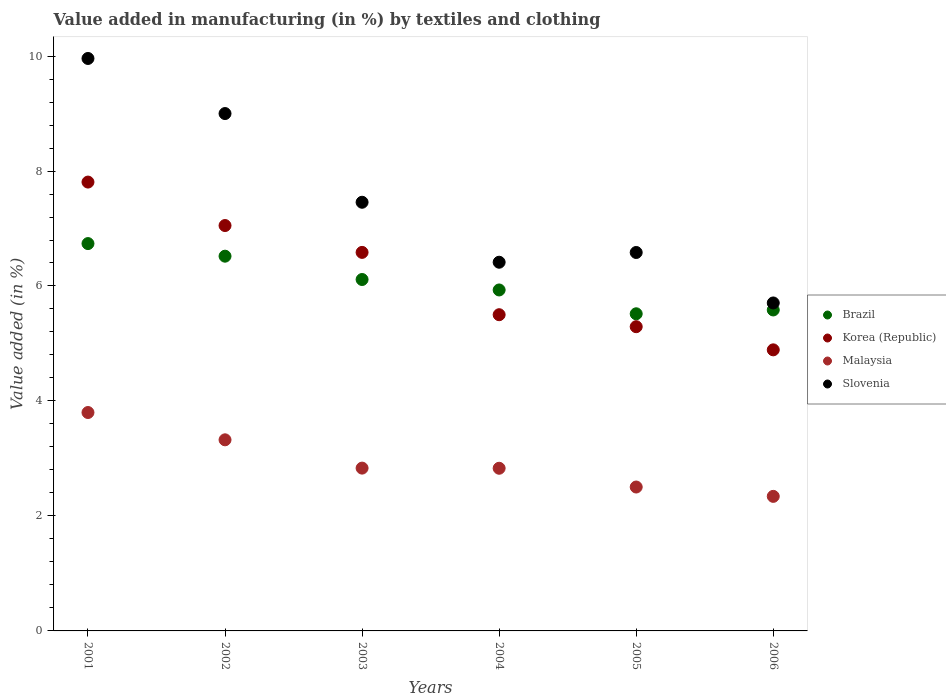How many different coloured dotlines are there?
Provide a succinct answer. 4. What is the percentage of value added in manufacturing by textiles and clothing in Malaysia in 2002?
Make the answer very short. 3.32. Across all years, what is the maximum percentage of value added in manufacturing by textiles and clothing in Brazil?
Your answer should be compact. 6.74. Across all years, what is the minimum percentage of value added in manufacturing by textiles and clothing in Brazil?
Provide a short and direct response. 5.52. In which year was the percentage of value added in manufacturing by textiles and clothing in Slovenia minimum?
Ensure brevity in your answer.  2006. What is the total percentage of value added in manufacturing by textiles and clothing in Korea (Republic) in the graph?
Offer a terse response. 37.13. What is the difference between the percentage of value added in manufacturing by textiles and clothing in Korea (Republic) in 2003 and that in 2006?
Provide a succinct answer. 1.7. What is the difference between the percentage of value added in manufacturing by textiles and clothing in Slovenia in 2004 and the percentage of value added in manufacturing by textiles and clothing in Korea (Republic) in 2001?
Ensure brevity in your answer.  -1.39. What is the average percentage of value added in manufacturing by textiles and clothing in Slovenia per year?
Ensure brevity in your answer.  7.52. In the year 2001, what is the difference between the percentage of value added in manufacturing by textiles and clothing in Brazil and percentage of value added in manufacturing by textiles and clothing in Slovenia?
Your answer should be very brief. -3.22. In how many years, is the percentage of value added in manufacturing by textiles and clothing in Brazil greater than 9.6 %?
Make the answer very short. 0. What is the ratio of the percentage of value added in manufacturing by textiles and clothing in Korea (Republic) in 2001 to that in 2002?
Provide a succinct answer. 1.11. What is the difference between the highest and the second highest percentage of value added in manufacturing by textiles and clothing in Brazil?
Ensure brevity in your answer.  0.22. What is the difference between the highest and the lowest percentage of value added in manufacturing by textiles and clothing in Korea (Republic)?
Offer a terse response. 2.92. In how many years, is the percentage of value added in manufacturing by textiles and clothing in Brazil greater than the average percentage of value added in manufacturing by textiles and clothing in Brazil taken over all years?
Your answer should be very brief. 3. Is it the case that in every year, the sum of the percentage of value added in manufacturing by textiles and clothing in Korea (Republic) and percentage of value added in manufacturing by textiles and clothing in Slovenia  is greater than the percentage of value added in manufacturing by textiles and clothing in Brazil?
Your answer should be very brief. Yes. Is the percentage of value added in manufacturing by textiles and clothing in Malaysia strictly greater than the percentage of value added in manufacturing by textiles and clothing in Slovenia over the years?
Give a very brief answer. No. What is the difference between two consecutive major ticks on the Y-axis?
Provide a succinct answer. 2. Are the values on the major ticks of Y-axis written in scientific E-notation?
Your answer should be very brief. No. Does the graph contain any zero values?
Your response must be concise. No. Where does the legend appear in the graph?
Give a very brief answer. Center right. How are the legend labels stacked?
Your answer should be compact. Vertical. What is the title of the graph?
Provide a short and direct response. Value added in manufacturing (in %) by textiles and clothing. Does "Bhutan" appear as one of the legend labels in the graph?
Your response must be concise. No. What is the label or title of the Y-axis?
Provide a short and direct response. Value added (in %). What is the Value added (in %) in Brazil in 2001?
Make the answer very short. 6.74. What is the Value added (in %) of Korea (Republic) in 2001?
Ensure brevity in your answer.  7.81. What is the Value added (in %) in Malaysia in 2001?
Keep it short and to the point. 3.8. What is the Value added (in %) of Slovenia in 2001?
Your response must be concise. 9.96. What is the Value added (in %) in Brazil in 2002?
Your answer should be very brief. 6.52. What is the Value added (in %) in Korea (Republic) in 2002?
Keep it short and to the point. 7.05. What is the Value added (in %) in Malaysia in 2002?
Ensure brevity in your answer.  3.32. What is the Value added (in %) of Slovenia in 2002?
Provide a succinct answer. 9. What is the Value added (in %) of Brazil in 2003?
Offer a very short reply. 6.11. What is the Value added (in %) of Korea (Republic) in 2003?
Keep it short and to the point. 6.58. What is the Value added (in %) of Malaysia in 2003?
Your answer should be compact. 2.83. What is the Value added (in %) of Slovenia in 2003?
Ensure brevity in your answer.  7.46. What is the Value added (in %) in Brazil in 2004?
Make the answer very short. 5.93. What is the Value added (in %) in Korea (Republic) in 2004?
Your response must be concise. 5.5. What is the Value added (in %) of Malaysia in 2004?
Your response must be concise. 2.83. What is the Value added (in %) of Slovenia in 2004?
Give a very brief answer. 6.41. What is the Value added (in %) in Brazil in 2005?
Offer a terse response. 5.52. What is the Value added (in %) of Korea (Republic) in 2005?
Your response must be concise. 5.29. What is the Value added (in %) of Malaysia in 2005?
Provide a short and direct response. 2.5. What is the Value added (in %) of Slovenia in 2005?
Keep it short and to the point. 6.58. What is the Value added (in %) of Brazil in 2006?
Your response must be concise. 5.58. What is the Value added (in %) of Korea (Republic) in 2006?
Ensure brevity in your answer.  4.89. What is the Value added (in %) of Malaysia in 2006?
Give a very brief answer. 2.34. What is the Value added (in %) of Slovenia in 2006?
Make the answer very short. 5.7. Across all years, what is the maximum Value added (in %) in Brazil?
Offer a very short reply. 6.74. Across all years, what is the maximum Value added (in %) of Korea (Republic)?
Provide a succinct answer. 7.81. Across all years, what is the maximum Value added (in %) of Malaysia?
Offer a very short reply. 3.8. Across all years, what is the maximum Value added (in %) of Slovenia?
Offer a very short reply. 9.96. Across all years, what is the minimum Value added (in %) in Brazil?
Your answer should be very brief. 5.52. Across all years, what is the minimum Value added (in %) of Korea (Republic)?
Make the answer very short. 4.89. Across all years, what is the minimum Value added (in %) in Malaysia?
Provide a short and direct response. 2.34. Across all years, what is the minimum Value added (in %) in Slovenia?
Offer a terse response. 5.7. What is the total Value added (in %) of Brazil in the graph?
Ensure brevity in your answer.  36.4. What is the total Value added (in %) of Korea (Republic) in the graph?
Offer a very short reply. 37.13. What is the total Value added (in %) of Malaysia in the graph?
Your response must be concise. 17.63. What is the total Value added (in %) in Slovenia in the graph?
Offer a very short reply. 45.11. What is the difference between the Value added (in %) in Brazil in 2001 and that in 2002?
Keep it short and to the point. 0.22. What is the difference between the Value added (in %) of Korea (Republic) in 2001 and that in 2002?
Ensure brevity in your answer.  0.76. What is the difference between the Value added (in %) of Malaysia in 2001 and that in 2002?
Offer a very short reply. 0.47. What is the difference between the Value added (in %) in Slovenia in 2001 and that in 2002?
Keep it short and to the point. 0.96. What is the difference between the Value added (in %) in Brazil in 2001 and that in 2003?
Make the answer very short. 0.62. What is the difference between the Value added (in %) of Korea (Republic) in 2001 and that in 2003?
Provide a short and direct response. 1.22. What is the difference between the Value added (in %) in Malaysia in 2001 and that in 2003?
Offer a very short reply. 0.97. What is the difference between the Value added (in %) in Slovenia in 2001 and that in 2003?
Your answer should be very brief. 2.5. What is the difference between the Value added (in %) of Brazil in 2001 and that in 2004?
Provide a succinct answer. 0.81. What is the difference between the Value added (in %) in Korea (Republic) in 2001 and that in 2004?
Provide a succinct answer. 2.31. What is the difference between the Value added (in %) of Malaysia in 2001 and that in 2004?
Your answer should be compact. 0.97. What is the difference between the Value added (in %) of Slovenia in 2001 and that in 2004?
Offer a terse response. 3.54. What is the difference between the Value added (in %) in Brazil in 2001 and that in 2005?
Make the answer very short. 1.22. What is the difference between the Value added (in %) in Korea (Republic) in 2001 and that in 2005?
Make the answer very short. 2.52. What is the difference between the Value added (in %) of Malaysia in 2001 and that in 2005?
Make the answer very short. 1.3. What is the difference between the Value added (in %) of Slovenia in 2001 and that in 2005?
Offer a very short reply. 3.38. What is the difference between the Value added (in %) in Brazil in 2001 and that in 2006?
Give a very brief answer. 1.15. What is the difference between the Value added (in %) in Korea (Republic) in 2001 and that in 2006?
Ensure brevity in your answer.  2.92. What is the difference between the Value added (in %) of Malaysia in 2001 and that in 2006?
Offer a very short reply. 1.46. What is the difference between the Value added (in %) in Slovenia in 2001 and that in 2006?
Your answer should be compact. 4.25. What is the difference between the Value added (in %) of Brazil in 2002 and that in 2003?
Your response must be concise. 0.41. What is the difference between the Value added (in %) of Korea (Republic) in 2002 and that in 2003?
Offer a very short reply. 0.47. What is the difference between the Value added (in %) of Malaysia in 2002 and that in 2003?
Your answer should be very brief. 0.49. What is the difference between the Value added (in %) in Slovenia in 2002 and that in 2003?
Ensure brevity in your answer.  1.54. What is the difference between the Value added (in %) in Brazil in 2002 and that in 2004?
Give a very brief answer. 0.59. What is the difference between the Value added (in %) of Korea (Republic) in 2002 and that in 2004?
Your response must be concise. 1.55. What is the difference between the Value added (in %) in Malaysia in 2002 and that in 2004?
Offer a very short reply. 0.49. What is the difference between the Value added (in %) of Slovenia in 2002 and that in 2004?
Keep it short and to the point. 2.59. What is the difference between the Value added (in %) in Brazil in 2002 and that in 2005?
Your answer should be compact. 1. What is the difference between the Value added (in %) in Korea (Republic) in 2002 and that in 2005?
Keep it short and to the point. 1.76. What is the difference between the Value added (in %) in Malaysia in 2002 and that in 2005?
Your answer should be compact. 0.82. What is the difference between the Value added (in %) in Slovenia in 2002 and that in 2005?
Ensure brevity in your answer.  2.42. What is the difference between the Value added (in %) in Brazil in 2002 and that in 2006?
Your response must be concise. 0.94. What is the difference between the Value added (in %) of Korea (Republic) in 2002 and that in 2006?
Your answer should be very brief. 2.16. What is the difference between the Value added (in %) in Malaysia in 2002 and that in 2006?
Your response must be concise. 0.98. What is the difference between the Value added (in %) of Slovenia in 2002 and that in 2006?
Provide a succinct answer. 3.29. What is the difference between the Value added (in %) of Brazil in 2003 and that in 2004?
Your answer should be compact. 0.18. What is the difference between the Value added (in %) in Korea (Republic) in 2003 and that in 2004?
Your answer should be very brief. 1.08. What is the difference between the Value added (in %) in Malaysia in 2003 and that in 2004?
Offer a terse response. 0. What is the difference between the Value added (in %) of Slovenia in 2003 and that in 2004?
Offer a very short reply. 1.04. What is the difference between the Value added (in %) in Brazil in 2003 and that in 2005?
Provide a short and direct response. 0.6. What is the difference between the Value added (in %) of Korea (Republic) in 2003 and that in 2005?
Offer a very short reply. 1.29. What is the difference between the Value added (in %) of Malaysia in 2003 and that in 2005?
Your answer should be compact. 0.33. What is the difference between the Value added (in %) in Slovenia in 2003 and that in 2005?
Provide a succinct answer. 0.87. What is the difference between the Value added (in %) in Brazil in 2003 and that in 2006?
Provide a short and direct response. 0.53. What is the difference between the Value added (in %) in Korea (Republic) in 2003 and that in 2006?
Your answer should be compact. 1.7. What is the difference between the Value added (in %) in Malaysia in 2003 and that in 2006?
Provide a short and direct response. 0.49. What is the difference between the Value added (in %) of Slovenia in 2003 and that in 2006?
Provide a succinct answer. 1.75. What is the difference between the Value added (in %) of Brazil in 2004 and that in 2005?
Your answer should be very brief. 0.41. What is the difference between the Value added (in %) in Korea (Republic) in 2004 and that in 2005?
Your answer should be very brief. 0.21. What is the difference between the Value added (in %) of Malaysia in 2004 and that in 2005?
Offer a terse response. 0.33. What is the difference between the Value added (in %) in Slovenia in 2004 and that in 2005?
Provide a short and direct response. -0.17. What is the difference between the Value added (in %) of Brazil in 2004 and that in 2006?
Provide a succinct answer. 0.35. What is the difference between the Value added (in %) in Korea (Republic) in 2004 and that in 2006?
Your answer should be very brief. 0.61. What is the difference between the Value added (in %) in Malaysia in 2004 and that in 2006?
Offer a very short reply. 0.49. What is the difference between the Value added (in %) of Slovenia in 2004 and that in 2006?
Give a very brief answer. 0.71. What is the difference between the Value added (in %) of Brazil in 2005 and that in 2006?
Make the answer very short. -0.07. What is the difference between the Value added (in %) of Korea (Republic) in 2005 and that in 2006?
Ensure brevity in your answer.  0.4. What is the difference between the Value added (in %) of Malaysia in 2005 and that in 2006?
Provide a succinct answer. 0.16. What is the difference between the Value added (in %) of Slovenia in 2005 and that in 2006?
Make the answer very short. 0.88. What is the difference between the Value added (in %) in Brazil in 2001 and the Value added (in %) in Korea (Republic) in 2002?
Give a very brief answer. -0.31. What is the difference between the Value added (in %) in Brazil in 2001 and the Value added (in %) in Malaysia in 2002?
Make the answer very short. 3.41. What is the difference between the Value added (in %) of Brazil in 2001 and the Value added (in %) of Slovenia in 2002?
Keep it short and to the point. -2.26. What is the difference between the Value added (in %) in Korea (Republic) in 2001 and the Value added (in %) in Malaysia in 2002?
Provide a short and direct response. 4.48. What is the difference between the Value added (in %) of Korea (Republic) in 2001 and the Value added (in %) of Slovenia in 2002?
Offer a terse response. -1.19. What is the difference between the Value added (in %) in Malaysia in 2001 and the Value added (in %) in Slovenia in 2002?
Give a very brief answer. -5.2. What is the difference between the Value added (in %) of Brazil in 2001 and the Value added (in %) of Korea (Republic) in 2003?
Make the answer very short. 0.15. What is the difference between the Value added (in %) in Brazil in 2001 and the Value added (in %) in Malaysia in 2003?
Keep it short and to the point. 3.91. What is the difference between the Value added (in %) in Brazil in 2001 and the Value added (in %) in Slovenia in 2003?
Provide a succinct answer. -0.72. What is the difference between the Value added (in %) of Korea (Republic) in 2001 and the Value added (in %) of Malaysia in 2003?
Offer a very short reply. 4.98. What is the difference between the Value added (in %) of Korea (Republic) in 2001 and the Value added (in %) of Slovenia in 2003?
Provide a succinct answer. 0.35. What is the difference between the Value added (in %) of Malaysia in 2001 and the Value added (in %) of Slovenia in 2003?
Provide a short and direct response. -3.66. What is the difference between the Value added (in %) of Brazil in 2001 and the Value added (in %) of Korea (Republic) in 2004?
Your response must be concise. 1.24. What is the difference between the Value added (in %) in Brazil in 2001 and the Value added (in %) in Malaysia in 2004?
Offer a terse response. 3.91. What is the difference between the Value added (in %) of Brazil in 2001 and the Value added (in %) of Slovenia in 2004?
Provide a succinct answer. 0.32. What is the difference between the Value added (in %) of Korea (Republic) in 2001 and the Value added (in %) of Malaysia in 2004?
Your answer should be compact. 4.98. What is the difference between the Value added (in %) of Korea (Republic) in 2001 and the Value added (in %) of Slovenia in 2004?
Give a very brief answer. 1.39. What is the difference between the Value added (in %) in Malaysia in 2001 and the Value added (in %) in Slovenia in 2004?
Give a very brief answer. -2.61. What is the difference between the Value added (in %) in Brazil in 2001 and the Value added (in %) in Korea (Republic) in 2005?
Provide a short and direct response. 1.45. What is the difference between the Value added (in %) in Brazil in 2001 and the Value added (in %) in Malaysia in 2005?
Your answer should be very brief. 4.23. What is the difference between the Value added (in %) in Brazil in 2001 and the Value added (in %) in Slovenia in 2005?
Keep it short and to the point. 0.15. What is the difference between the Value added (in %) of Korea (Republic) in 2001 and the Value added (in %) of Malaysia in 2005?
Ensure brevity in your answer.  5.3. What is the difference between the Value added (in %) of Korea (Republic) in 2001 and the Value added (in %) of Slovenia in 2005?
Keep it short and to the point. 1.22. What is the difference between the Value added (in %) of Malaysia in 2001 and the Value added (in %) of Slovenia in 2005?
Ensure brevity in your answer.  -2.78. What is the difference between the Value added (in %) in Brazil in 2001 and the Value added (in %) in Korea (Republic) in 2006?
Provide a succinct answer. 1.85. What is the difference between the Value added (in %) of Brazil in 2001 and the Value added (in %) of Malaysia in 2006?
Your answer should be very brief. 4.4. What is the difference between the Value added (in %) in Brazil in 2001 and the Value added (in %) in Slovenia in 2006?
Offer a very short reply. 1.03. What is the difference between the Value added (in %) in Korea (Republic) in 2001 and the Value added (in %) in Malaysia in 2006?
Give a very brief answer. 5.47. What is the difference between the Value added (in %) of Korea (Republic) in 2001 and the Value added (in %) of Slovenia in 2006?
Give a very brief answer. 2.1. What is the difference between the Value added (in %) in Malaysia in 2001 and the Value added (in %) in Slovenia in 2006?
Provide a short and direct response. -1.91. What is the difference between the Value added (in %) in Brazil in 2002 and the Value added (in %) in Korea (Republic) in 2003?
Give a very brief answer. -0.07. What is the difference between the Value added (in %) in Brazil in 2002 and the Value added (in %) in Malaysia in 2003?
Your answer should be compact. 3.69. What is the difference between the Value added (in %) in Brazil in 2002 and the Value added (in %) in Slovenia in 2003?
Make the answer very short. -0.94. What is the difference between the Value added (in %) of Korea (Republic) in 2002 and the Value added (in %) of Malaysia in 2003?
Your answer should be compact. 4.22. What is the difference between the Value added (in %) of Korea (Republic) in 2002 and the Value added (in %) of Slovenia in 2003?
Offer a very short reply. -0.4. What is the difference between the Value added (in %) in Malaysia in 2002 and the Value added (in %) in Slovenia in 2003?
Make the answer very short. -4.13. What is the difference between the Value added (in %) in Brazil in 2002 and the Value added (in %) in Korea (Republic) in 2004?
Ensure brevity in your answer.  1.02. What is the difference between the Value added (in %) of Brazil in 2002 and the Value added (in %) of Malaysia in 2004?
Offer a very short reply. 3.69. What is the difference between the Value added (in %) of Brazil in 2002 and the Value added (in %) of Slovenia in 2004?
Your response must be concise. 0.11. What is the difference between the Value added (in %) of Korea (Republic) in 2002 and the Value added (in %) of Malaysia in 2004?
Keep it short and to the point. 4.22. What is the difference between the Value added (in %) of Korea (Republic) in 2002 and the Value added (in %) of Slovenia in 2004?
Ensure brevity in your answer.  0.64. What is the difference between the Value added (in %) of Malaysia in 2002 and the Value added (in %) of Slovenia in 2004?
Make the answer very short. -3.09. What is the difference between the Value added (in %) in Brazil in 2002 and the Value added (in %) in Korea (Republic) in 2005?
Offer a terse response. 1.23. What is the difference between the Value added (in %) in Brazil in 2002 and the Value added (in %) in Malaysia in 2005?
Provide a succinct answer. 4.02. What is the difference between the Value added (in %) in Brazil in 2002 and the Value added (in %) in Slovenia in 2005?
Provide a succinct answer. -0.06. What is the difference between the Value added (in %) of Korea (Republic) in 2002 and the Value added (in %) of Malaysia in 2005?
Your answer should be very brief. 4.55. What is the difference between the Value added (in %) in Korea (Republic) in 2002 and the Value added (in %) in Slovenia in 2005?
Provide a succinct answer. 0.47. What is the difference between the Value added (in %) of Malaysia in 2002 and the Value added (in %) of Slovenia in 2005?
Your response must be concise. -3.26. What is the difference between the Value added (in %) in Brazil in 2002 and the Value added (in %) in Korea (Republic) in 2006?
Provide a short and direct response. 1.63. What is the difference between the Value added (in %) of Brazil in 2002 and the Value added (in %) of Malaysia in 2006?
Ensure brevity in your answer.  4.18. What is the difference between the Value added (in %) in Brazil in 2002 and the Value added (in %) in Slovenia in 2006?
Make the answer very short. 0.81. What is the difference between the Value added (in %) in Korea (Republic) in 2002 and the Value added (in %) in Malaysia in 2006?
Provide a short and direct response. 4.71. What is the difference between the Value added (in %) in Korea (Republic) in 2002 and the Value added (in %) in Slovenia in 2006?
Your answer should be compact. 1.35. What is the difference between the Value added (in %) in Malaysia in 2002 and the Value added (in %) in Slovenia in 2006?
Ensure brevity in your answer.  -2.38. What is the difference between the Value added (in %) in Brazil in 2003 and the Value added (in %) in Korea (Republic) in 2004?
Provide a short and direct response. 0.61. What is the difference between the Value added (in %) in Brazil in 2003 and the Value added (in %) in Malaysia in 2004?
Give a very brief answer. 3.28. What is the difference between the Value added (in %) in Brazil in 2003 and the Value added (in %) in Slovenia in 2004?
Your answer should be compact. -0.3. What is the difference between the Value added (in %) in Korea (Republic) in 2003 and the Value added (in %) in Malaysia in 2004?
Provide a short and direct response. 3.76. What is the difference between the Value added (in %) of Korea (Republic) in 2003 and the Value added (in %) of Slovenia in 2004?
Offer a terse response. 0.17. What is the difference between the Value added (in %) of Malaysia in 2003 and the Value added (in %) of Slovenia in 2004?
Make the answer very short. -3.58. What is the difference between the Value added (in %) of Brazil in 2003 and the Value added (in %) of Korea (Republic) in 2005?
Provide a short and direct response. 0.82. What is the difference between the Value added (in %) of Brazil in 2003 and the Value added (in %) of Malaysia in 2005?
Provide a short and direct response. 3.61. What is the difference between the Value added (in %) of Brazil in 2003 and the Value added (in %) of Slovenia in 2005?
Your answer should be compact. -0.47. What is the difference between the Value added (in %) of Korea (Republic) in 2003 and the Value added (in %) of Malaysia in 2005?
Provide a succinct answer. 4.08. What is the difference between the Value added (in %) of Korea (Republic) in 2003 and the Value added (in %) of Slovenia in 2005?
Make the answer very short. 0. What is the difference between the Value added (in %) of Malaysia in 2003 and the Value added (in %) of Slovenia in 2005?
Your answer should be very brief. -3.75. What is the difference between the Value added (in %) of Brazil in 2003 and the Value added (in %) of Korea (Republic) in 2006?
Ensure brevity in your answer.  1.22. What is the difference between the Value added (in %) of Brazil in 2003 and the Value added (in %) of Malaysia in 2006?
Ensure brevity in your answer.  3.77. What is the difference between the Value added (in %) in Brazil in 2003 and the Value added (in %) in Slovenia in 2006?
Keep it short and to the point. 0.41. What is the difference between the Value added (in %) in Korea (Republic) in 2003 and the Value added (in %) in Malaysia in 2006?
Ensure brevity in your answer.  4.24. What is the difference between the Value added (in %) of Korea (Republic) in 2003 and the Value added (in %) of Slovenia in 2006?
Provide a succinct answer. 0.88. What is the difference between the Value added (in %) in Malaysia in 2003 and the Value added (in %) in Slovenia in 2006?
Your answer should be very brief. -2.87. What is the difference between the Value added (in %) in Brazil in 2004 and the Value added (in %) in Korea (Republic) in 2005?
Your response must be concise. 0.64. What is the difference between the Value added (in %) of Brazil in 2004 and the Value added (in %) of Malaysia in 2005?
Provide a succinct answer. 3.43. What is the difference between the Value added (in %) of Brazil in 2004 and the Value added (in %) of Slovenia in 2005?
Provide a short and direct response. -0.65. What is the difference between the Value added (in %) in Korea (Republic) in 2004 and the Value added (in %) in Malaysia in 2005?
Ensure brevity in your answer.  3. What is the difference between the Value added (in %) in Korea (Republic) in 2004 and the Value added (in %) in Slovenia in 2005?
Your answer should be very brief. -1.08. What is the difference between the Value added (in %) of Malaysia in 2004 and the Value added (in %) of Slovenia in 2005?
Offer a very short reply. -3.75. What is the difference between the Value added (in %) in Brazil in 2004 and the Value added (in %) in Korea (Republic) in 2006?
Offer a terse response. 1.04. What is the difference between the Value added (in %) in Brazil in 2004 and the Value added (in %) in Malaysia in 2006?
Your answer should be compact. 3.59. What is the difference between the Value added (in %) of Brazil in 2004 and the Value added (in %) of Slovenia in 2006?
Offer a terse response. 0.23. What is the difference between the Value added (in %) of Korea (Republic) in 2004 and the Value added (in %) of Malaysia in 2006?
Offer a terse response. 3.16. What is the difference between the Value added (in %) of Korea (Republic) in 2004 and the Value added (in %) of Slovenia in 2006?
Make the answer very short. -0.2. What is the difference between the Value added (in %) in Malaysia in 2004 and the Value added (in %) in Slovenia in 2006?
Offer a very short reply. -2.88. What is the difference between the Value added (in %) of Brazil in 2005 and the Value added (in %) of Korea (Republic) in 2006?
Your response must be concise. 0.63. What is the difference between the Value added (in %) in Brazil in 2005 and the Value added (in %) in Malaysia in 2006?
Offer a very short reply. 3.18. What is the difference between the Value added (in %) of Brazil in 2005 and the Value added (in %) of Slovenia in 2006?
Give a very brief answer. -0.19. What is the difference between the Value added (in %) in Korea (Republic) in 2005 and the Value added (in %) in Malaysia in 2006?
Provide a short and direct response. 2.95. What is the difference between the Value added (in %) in Korea (Republic) in 2005 and the Value added (in %) in Slovenia in 2006?
Your answer should be compact. -0.41. What is the difference between the Value added (in %) of Malaysia in 2005 and the Value added (in %) of Slovenia in 2006?
Ensure brevity in your answer.  -3.2. What is the average Value added (in %) of Brazil per year?
Provide a succinct answer. 6.07. What is the average Value added (in %) in Korea (Republic) per year?
Offer a very short reply. 6.19. What is the average Value added (in %) of Malaysia per year?
Your response must be concise. 2.94. What is the average Value added (in %) of Slovenia per year?
Your answer should be very brief. 7.52. In the year 2001, what is the difference between the Value added (in %) of Brazil and Value added (in %) of Korea (Republic)?
Ensure brevity in your answer.  -1.07. In the year 2001, what is the difference between the Value added (in %) in Brazil and Value added (in %) in Malaysia?
Provide a short and direct response. 2.94. In the year 2001, what is the difference between the Value added (in %) in Brazil and Value added (in %) in Slovenia?
Provide a short and direct response. -3.22. In the year 2001, what is the difference between the Value added (in %) in Korea (Republic) and Value added (in %) in Malaysia?
Give a very brief answer. 4.01. In the year 2001, what is the difference between the Value added (in %) in Korea (Republic) and Value added (in %) in Slovenia?
Your answer should be very brief. -2.15. In the year 2001, what is the difference between the Value added (in %) of Malaysia and Value added (in %) of Slovenia?
Provide a succinct answer. -6.16. In the year 2002, what is the difference between the Value added (in %) of Brazil and Value added (in %) of Korea (Republic)?
Your answer should be compact. -0.53. In the year 2002, what is the difference between the Value added (in %) of Brazil and Value added (in %) of Malaysia?
Provide a succinct answer. 3.19. In the year 2002, what is the difference between the Value added (in %) of Brazil and Value added (in %) of Slovenia?
Keep it short and to the point. -2.48. In the year 2002, what is the difference between the Value added (in %) of Korea (Republic) and Value added (in %) of Malaysia?
Offer a terse response. 3.73. In the year 2002, what is the difference between the Value added (in %) in Korea (Republic) and Value added (in %) in Slovenia?
Your answer should be very brief. -1.95. In the year 2002, what is the difference between the Value added (in %) of Malaysia and Value added (in %) of Slovenia?
Make the answer very short. -5.68. In the year 2003, what is the difference between the Value added (in %) of Brazil and Value added (in %) of Korea (Republic)?
Make the answer very short. -0.47. In the year 2003, what is the difference between the Value added (in %) in Brazil and Value added (in %) in Malaysia?
Keep it short and to the point. 3.28. In the year 2003, what is the difference between the Value added (in %) in Brazil and Value added (in %) in Slovenia?
Your answer should be very brief. -1.34. In the year 2003, what is the difference between the Value added (in %) of Korea (Republic) and Value added (in %) of Malaysia?
Provide a short and direct response. 3.75. In the year 2003, what is the difference between the Value added (in %) of Korea (Republic) and Value added (in %) of Slovenia?
Your answer should be very brief. -0.87. In the year 2003, what is the difference between the Value added (in %) in Malaysia and Value added (in %) in Slovenia?
Give a very brief answer. -4.62. In the year 2004, what is the difference between the Value added (in %) in Brazil and Value added (in %) in Korea (Republic)?
Your answer should be compact. 0.43. In the year 2004, what is the difference between the Value added (in %) of Brazil and Value added (in %) of Malaysia?
Give a very brief answer. 3.1. In the year 2004, what is the difference between the Value added (in %) in Brazil and Value added (in %) in Slovenia?
Your response must be concise. -0.48. In the year 2004, what is the difference between the Value added (in %) in Korea (Republic) and Value added (in %) in Malaysia?
Ensure brevity in your answer.  2.67. In the year 2004, what is the difference between the Value added (in %) in Korea (Republic) and Value added (in %) in Slovenia?
Keep it short and to the point. -0.91. In the year 2004, what is the difference between the Value added (in %) in Malaysia and Value added (in %) in Slovenia?
Offer a terse response. -3.58. In the year 2005, what is the difference between the Value added (in %) of Brazil and Value added (in %) of Korea (Republic)?
Keep it short and to the point. 0.22. In the year 2005, what is the difference between the Value added (in %) in Brazil and Value added (in %) in Malaysia?
Offer a very short reply. 3.01. In the year 2005, what is the difference between the Value added (in %) of Brazil and Value added (in %) of Slovenia?
Your answer should be compact. -1.07. In the year 2005, what is the difference between the Value added (in %) of Korea (Republic) and Value added (in %) of Malaysia?
Make the answer very short. 2.79. In the year 2005, what is the difference between the Value added (in %) in Korea (Republic) and Value added (in %) in Slovenia?
Your answer should be compact. -1.29. In the year 2005, what is the difference between the Value added (in %) of Malaysia and Value added (in %) of Slovenia?
Your answer should be very brief. -4.08. In the year 2006, what is the difference between the Value added (in %) of Brazil and Value added (in %) of Korea (Republic)?
Offer a very short reply. 0.69. In the year 2006, what is the difference between the Value added (in %) in Brazil and Value added (in %) in Malaysia?
Offer a terse response. 3.24. In the year 2006, what is the difference between the Value added (in %) in Brazil and Value added (in %) in Slovenia?
Provide a short and direct response. -0.12. In the year 2006, what is the difference between the Value added (in %) in Korea (Republic) and Value added (in %) in Malaysia?
Ensure brevity in your answer.  2.55. In the year 2006, what is the difference between the Value added (in %) in Korea (Republic) and Value added (in %) in Slovenia?
Your answer should be compact. -0.82. In the year 2006, what is the difference between the Value added (in %) of Malaysia and Value added (in %) of Slovenia?
Your answer should be very brief. -3.36. What is the ratio of the Value added (in %) in Brazil in 2001 to that in 2002?
Your answer should be compact. 1.03. What is the ratio of the Value added (in %) of Korea (Republic) in 2001 to that in 2002?
Offer a terse response. 1.11. What is the ratio of the Value added (in %) in Malaysia in 2001 to that in 2002?
Provide a short and direct response. 1.14. What is the ratio of the Value added (in %) in Slovenia in 2001 to that in 2002?
Keep it short and to the point. 1.11. What is the ratio of the Value added (in %) in Brazil in 2001 to that in 2003?
Make the answer very short. 1.1. What is the ratio of the Value added (in %) in Korea (Republic) in 2001 to that in 2003?
Give a very brief answer. 1.19. What is the ratio of the Value added (in %) of Malaysia in 2001 to that in 2003?
Provide a succinct answer. 1.34. What is the ratio of the Value added (in %) in Slovenia in 2001 to that in 2003?
Give a very brief answer. 1.34. What is the ratio of the Value added (in %) of Brazil in 2001 to that in 2004?
Ensure brevity in your answer.  1.14. What is the ratio of the Value added (in %) in Korea (Republic) in 2001 to that in 2004?
Provide a succinct answer. 1.42. What is the ratio of the Value added (in %) of Malaysia in 2001 to that in 2004?
Keep it short and to the point. 1.34. What is the ratio of the Value added (in %) in Slovenia in 2001 to that in 2004?
Give a very brief answer. 1.55. What is the ratio of the Value added (in %) of Brazil in 2001 to that in 2005?
Offer a terse response. 1.22. What is the ratio of the Value added (in %) of Korea (Republic) in 2001 to that in 2005?
Ensure brevity in your answer.  1.48. What is the ratio of the Value added (in %) of Malaysia in 2001 to that in 2005?
Your answer should be very brief. 1.52. What is the ratio of the Value added (in %) in Slovenia in 2001 to that in 2005?
Your answer should be very brief. 1.51. What is the ratio of the Value added (in %) in Brazil in 2001 to that in 2006?
Make the answer very short. 1.21. What is the ratio of the Value added (in %) of Korea (Republic) in 2001 to that in 2006?
Make the answer very short. 1.6. What is the ratio of the Value added (in %) of Malaysia in 2001 to that in 2006?
Provide a succinct answer. 1.62. What is the ratio of the Value added (in %) in Slovenia in 2001 to that in 2006?
Ensure brevity in your answer.  1.75. What is the ratio of the Value added (in %) in Brazil in 2002 to that in 2003?
Provide a succinct answer. 1.07. What is the ratio of the Value added (in %) in Korea (Republic) in 2002 to that in 2003?
Offer a very short reply. 1.07. What is the ratio of the Value added (in %) of Malaysia in 2002 to that in 2003?
Your answer should be compact. 1.17. What is the ratio of the Value added (in %) in Slovenia in 2002 to that in 2003?
Provide a succinct answer. 1.21. What is the ratio of the Value added (in %) in Brazil in 2002 to that in 2004?
Ensure brevity in your answer.  1.1. What is the ratio of the Value added (in %) of Korea (Republic) in 2002 to that in 2004?
Provide a short and direct response. 1.28. What is the ratio of the Value added (in %) of Malaysia in 2002 to that in 2004?
Ensure brevity in your answer.  1.17. What is the ratio of the Value added (in %) of Slovenia in 2002 to that in 2004?
Give a very brief answer. 1.4. What is the ratio of the Value added (in %) in Brazil in 2002 to that in 2005?
Ensure brevity in your answer.  1.18. What is the ratio of the Value added (in %) of Korea (Republic) in 2002 to that in 2005?
Keep it short and to the point. 1.33. What is the ratio of the Value added (in %) in Malaysia in 2002 to that in 2005?
Provide a short and direct response. 1.33. What is the ratio of the Value added (in %) in Slovenia in 2002 to that in 2005?
Offer a terse response. 1.37. What is the ratio of the Value added (in %) of Brazil in 2002 to that in 2006?
Keep it short and to the point. 1.17. What is the ratio of the Value added (in %) in Korea (Republic) in 2002 to that in 2006?
Give a very brief answer. 1.44. What is the ratio of the Value added (in %) of Malaysia in 2002 to that in 2006?
Provide a short and direct response. 1.42. What is the ratio of the Value added (in %) of Slovenia in 2002 to that in 2006?
Provide a short and direct response. 1.58. What is the ratio of the Value added (in %) in Brazil in 2003 to that in 2004?
Keep it short and to the point. 1.03. What is the ratio of the Value added (in %) of Korea (Republic) in 2003 to that in 2004?
Keep it short and to the point. 1.2. What is the ratio of the Value added (in %) in Slovenia in 2003 to that in 2004?
Keep it short and to the point. 1.16. What is the ratio of the Value added (in %) in Brazil in 2003 to that in 2005?
Provide a succinct answer. 1.11. What is the ratio of the Value added (in %) of Korea (Republic) in 2003 to that in 2005?
Your answer should be very brief. 1.24. What is the ratio of the Value added (in %) of Malaysia in 2003 to that in 2005?
Your response must be concise. 1.13. What is the ratio of the Value added (in %) of Slovenia in 2003 to that in 2005?
Keep it short and to the point. 1.13. What is the ratio of the Value added (in %) in Brazil in 2003 to that in 2006?
Your answer should be very brief. 1.09. What is the ratio of the Value added (in %) in Korea (Republic) in 2003 to that in 2006?
Provide a short and direct response. 1.35. What is the ratio of the Value added (in %) of Malaysia in 2003 to that in 2006?
Provide a succinct answer. 1.21. What is the ratio of the Value added (in %) in Slovenia in 2003 to that in 2006?
Offer a terse response. 1.31. What is the ratio of the Value added (in %) in Brazil in 2004 to that in 2005?
Make the answer very short. 1.08. What is the ratio of the Value added (in %) in Korea (Republic) in 2004 to that in 2005?
Ensure brevity in your answer.  1.04. What is the ratio of the Value added (in %) in Malaysia in 2004 to that in 2005?
Provide a short and direct response. 1.13. What is the ratio of the Value added (in %) of Slovenia in 2004 to that in 2005?
Make the answer very short. 0.97. What is the ratio of the Value added (in %) of Brazil in 2004 to that in 2006?
Your answer should be compact. 1.06. What is the ratio of the Value added (in %) in Malaysia in 2004 to that in 2006?
Ensure brevity in your answer.  1.21. What is the ratio of the Value added (in %) of Slovenia in 2004 to that in 2006?
Ensure brevity in your answer.  1.12. What is the ratio of the Value added (in %) of Korea (Republic) in 2005 to that in 2006?
Offer a terse response. 1.08. What is the ratio of the Value added (in %) in Malaysia in 2005 to that in 2006?
Your response must be concise. 1.07. What is the ratio of the Value added (in %) in Slovenia in 2005 to that in 2006?
Provide a short and direct response. 1.15. What is the difference between the highest and the second highest Value added (in %) in Brazil?
Your answer should be very brief. 0.22. What is the difference between the highest and the second highest Value added (in %) in Korea (Republic)?
Give a very brief answer. 0.76. What is the difference between the highest and the second highest Value added (in %) in Malaysia?
Provide a short and direct response. 0.47. What is the difference between the highest and the second highest Value added (in %) of Slovenia?
Offer a terse response. 0.96. What is the difference between the highest and the lowest Value added (in %) in Brazil?
Your answer should be compact. 1.22. What is the difference between the highest and the lowest Value added (in %) of Korea (Republic)?
Keep it short and to the point. 2.92. What is the difference between the highest and the lowest Value added (in %) in Malaysia?
Ensure brevity in your answer.  1.46. What is the difference between the highest and the lowest Value added (in %) of Slovenia?
Give a very brief answer. 4.25. 